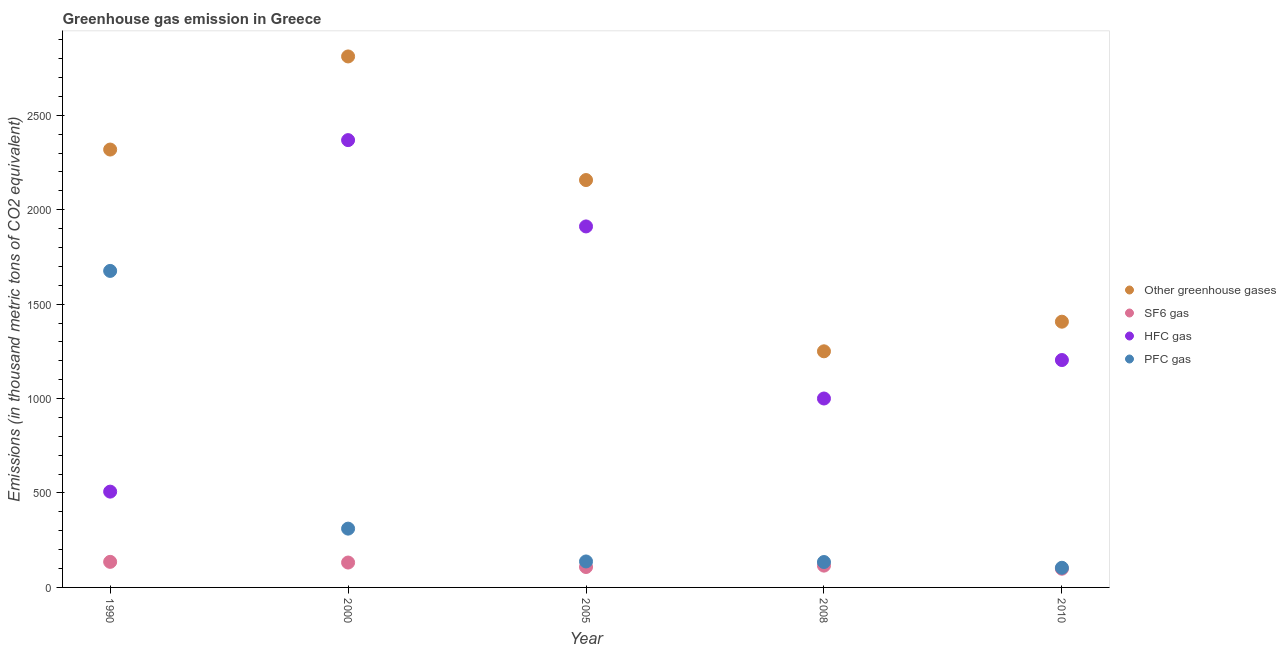How many different coloured dotlines are there?
Make the answer very short. 4. What is the emission of pfc gas in 2000?
Your response must be concise. 311.3. Across all years, what is the maximum emission of sf6 gas?
Your response must be concise. 135.4. Across all years, what is the minimum emission of hfc gas?
Keep it short and to the point. 507.2. In which year was the emission of sf6 gas minimum?
Give a very brief answer. 2010. What is the total emission of sf6 gas in the graph?
Offer a terse response. 589.7. What is the difference between the emission of hfc gas in 2000 and that in 2005?
Your response must be concise. 457. What is the difference between the emission of greenhouse gases in 2010 and the emission of sf6 gas in 1990?
Give a very brief answer. 1271.6. What is the average emission of pfc gas per year?
Offer a terse response. 472.64. In the year 2000, what is the difference between the emission of hfc gas and emission of sf6 gas?
Make the answer very short. 2236.6. In how many years, is the emission of hfc gas greater than 400 thousand metric tons?
Keep it short and to the point. 5. What is the ratio of the emission of pfc gas in 1990 to that in 2000?
Provide a succinct answer. 5.38. What is the difference between the highest and the second highest emission of sf6 gas?
Keep it short and to the point. 3.6. What is the difference between the highest and the lowest emission of pfc gas?
Ensure brevity in your answer.  1571.9. Is the sum of the emission of greenhouse gases in 1990 and 2008 greater than the maximum emission of hfc gas across all years?
Your answer should be very brief. Yes. Is it the case that in every year, the sum of the emission of sf6 gas and emission of greenhouse gases is greater than the sum of emission of pfc gas and emission of hfc gas?
Your response must be concise. Yes. Is it the case that in every year, the sum of the emission of greenhouse gases and emission of sf6 gas is greater than the emission of hfc gas?
Ensure brevity in your answer.  Yes. Does the emission of hfc gas monotonically increase over the years?
Keep it short and to the point. No. Is the emission of sf6 gas strictly greater than the emission of greenhouse gases over the years?
Your response must be concise. No. Is the emission of pfc gas strictly less than the emission of sf6 gas over the years?
Provide a succinct answer. No. How many years are there in the graph?
Provide a short and direct response. 5. Are the values on the major ticks of Y-axis written in scientific E-notation?
Your answer should be very brief. No. Does the graph contain any zero values?
Provide a short and direct response. No. Where does the legend appear in the graph?
Provide a short and direct response. Center right. How many legend labels are there?
Offer a very short reply. 4. How are the legend labels stacked?
Your answer should be very brief. Vertical. What is the title of the graph?
Provide a succinct answer. Greenhouse gas emission in Greece. Does "Bird species" appear as one of the legend labels in the graph?
Offer a terse response. No. What is the label or title of the X-axis?
Give a very brief answer. Year. What is the label or title of the Y-axis?
Keep it short and to the point. Emissions (in thousand metric tons of CO2 equivalent). What is the Emissions (in thousand metric tons of CO2 equivalent) of Other greenhouse gases in 1990?
Give a very brief answer. 2318.5. What is the Emissions (in thousand metric tons of CO2 equivalent) in SF6 gas in 1990?
Give a very brief answer. 135.4. What is the Emissions (in thousand metric tons of CO2 equivalent) in HFC gas in 1990?
Offer a very short reply. 507.2. What is the Emissions (in thousand metric tons of CO2 equivalent) in PFC gas in 1990?
Your answer should be very brief. 1675.9. What is the Emissions (in thousand metric tons of CO2 equivalent) in Other greenhouse gases in 2000?
Make the answer very short. 2811.5. What is the Emissions (in thousand metric tons of CO2 equivalent) of SF6 gas in 2000?
Provide a succinct answer. 131.8. What is the Emissions (in thousand metric tons of CO2 equivalent) of HFC gas in 2000?
Your answer should be compact. 2368.4. What is the Emissions (in thousand metric tons of CO2 equivalent) in PFC gas in 2000?
Keep it short and to the point. 311.3. What is the Emissions (in thousand metric tons of CO2 equivalent) in Other greenhouse gases in 2005?
Provide a succinct answer. 2157. What is the Emissions (in thousand metric tons of CO2 equivalent) of SF6 gas in 2005?
Ensure brevity in your answer.  108.1. What is the Emissions (in thousand metric tons of CO2 equivalent) of HFC gas in 2005?
Give a very brief answer. 1911.4. What is the Emissions (in thousand metric tons of CO2 equivalent) in PFC gas in 2005?
Make the answer very short. 137.5. What is the Emissions (in thousand metric tons of CO2 equivalent) in Other greenhouse gases in 2008?
Make the answer very short. 1250.2. What is the Emissions (in thousand metric tons of CO2 equivalent) of SF6 gas in 2008?
Keep it short and to the point. 115.4. What is the Emissions (in thousand metric tons of CO2 equivalent) of HFC gas in 2008?
Make the answer very short. 1000.3. What is the Emissions (in thousand metric tons of CO2 equivalent) in PFC gas in 2008?
Your answer should be compact. 134.5. What is the Emissions (in thousand metric tons of CO2 equivalent) in Other greenhouse gases in 2010?
Provide a short and direct response. 1407. What is the Emissions (in thousand metric tons of CO2 equivalent) in SF6 gas in 2010?
Ensure brevity in your answer.  99. What is the Emissions (in thousand metric tons of CO2 equivalent) of HFC gas in 2010?
Give a very brief answer. 1204. What is the Emissions (in thousand metric tons of CO2 equivalent) in PFC gas in 2010?
Offer a terse response. 104. Across all years, what is the maximum Emissions (in thousand metric tons of CO2 equivalent) in Other greenhouse gases?
Your answer should be compact. 2811.5. Across all years, what is the maximum Emissions (in thousand metric tons of CO2 equivalent) of SF6 gas?
Ensure brevity in your answer.  135.4. Across all years, what is the maximum Emissions (in thousand metric tons of CO2 equivalent) of HFC gas?
Offer a terse response. 2368.4. Across all years, what is the maximum Emissions (in thousand metric tons of CO2 equivalent) of PFC gas?
Provide a short and direct response. 1675.9. Across all years, what is the minimum Emissions (in thousand metric tons of CO2 equivalent) in Other greenhouse gases?
Your answer should be compact. 1250.2. Across all years, what is the minimum Emissions (in thousand metric tons of CO2 equivalent) in HFC gas?
Your response must be concise. 507.2. Across all years, what is the minimum Emissions (in thousand metric tons of CO2 equivalent) of PFC gas?
Keep it short and to the point. 104. What is the total Emissions (in thousand metric tons of CO2 equivalent) in Other greenhouse gases in the graph?
Provide a short and direct response. 9944.2. What is the total Emissions (in thousand metric tons of CO2 equivalent) of SF6 gas in the graph?
Your answer should be compact. 589.7. What is the total Emissions (in thousand metric tons of CO2 equivalent) in HFC gas in the graph?
Keep it short and to the point. 6991.3. What is the total Emissions (in thousand metric tons of CO2 equivalent) of PFC gas in the graph?
Offer a very short reply. 2363.2. What is the difference between the Emissions (in thousand metric tons of CO2 equivalent) in Other greenhouse gases in 1990 and that in 2000?
Provide a short and direct response. -493. What is the difference between the Emissions (in thousand metric tons of CO2 equivalent) in HFC gas in 1990 and that in 2000?
Your answer should be very brief. -1861.2. What is the difference between the Emissions (in thousand metric tons of CO2 equivalent) in PFC gas in 1990 and that in 2000?
Provide a short and direct response. 1364.6. What is the difference between the Emissions (in thousand metric tons of CO2 equivalent) in Other greenhouse gases in 1990 and that in 2005?
Ensure brevity in your answer.  161.5. What is the difference between the Emissions (in thousand metric tons of CO2 equivalent) in SF6 gas in 1990 and that in 2005?
Provide a succinct answer. 27.3. What is the difference between the Emissions (in thousand metric tons of CO2 equivalent) of HFC gas in 1990 and that in 2005?
Offer a very short reply. -1404.2. What is the difference between the Emissions (in thousand metric tons of CO2 equivalent) of PFC gas in 1990 and that in 2005?
Offer a terse response. 1538.4. What is the difference between the Emissions (in thousand metric tons of CO2 equivalent) of Other greenhouse gases in 1990 and that in 2008?
Offer a very short reply. 1068.3. What is the difference between the Emissions (in thousand metric tons of CO2 equivalent) of HFC gas in 1990 and that in 2008?
Give a very brief answer. -493.1. What is the difference between the Emissions (in thousand metric tons of CO2 equivalent) in PFC gas in 1990 and that in 2008?
Provide a short and direct response. 1541.4. What is the difference between the Emissions (in thousand metric tons of CO2 equivalent) in Other greenhouse gases in 1990 and that in 2010?
Keep it short and to the point. 911.5. What is the difference between the Emissions (in thousand metric tons of CO2 equivalent) in SF6 gas in 1990 and that in 2010?
Your answer should be very brief. 36.4. What is the difference between the Emissions (in thousand metric tons of CO2 equivalent) of HFC gas in 1990 and that in 2010?
Give a very brief answer. -696.8. What is the difference between the Emissions (in thousand metric tons of CO2 equivalent) of PFC gas in 1990 and that in 2010?
Give a very brief answer. 1571.9. What is the difference between the Emissions (in thousand metric tons of CO2 equivalent) of Other greenhouse gases in 2000 and that in 2005?
Your answer should be very brief. 654.5. What is the difference between the Emissions (in thousand metric tons of CO2 equivalent) of SF6 gas in 2000 and that in 2005?
Give a very brief answer. 23.7. What is the difference between the Emissions (in thousand metric tons of CO2 equivalent) of HFC gas in 2000 and that in 2005?
Your response must be concise. 457. What is the difference between the Emissions (in thousand metric tons of CO2 equivalent) of PFC gas in 2000 and that in 2005?
Your response must be concise. 173.8. What is the difference between the Emissions (in thousand metric tons of CO2 equivalent) in Other greenhouse gases in 2000 and that in 2008?
Provide a short and direct response. 1561.3. What is the difference between the Emissions (in thousand metric tons of CO2 equivalent) in SF6 gas in 2000 and that in 2008?
Keep it short and to the point. 16.4. What is the difference between the Emissions (in thousand metric tons of CO2 equivalent) of HFC gas in 2000 and that in 2008?
Provide a short and direct response. 1368.1. What is the difference between the Emissions (in thousand metric tons of CO2 equivalent) of PFC gas in 2000 and that in 2008?
Your response must be concise. 176.8. What is the difference between the Emissions (in thousand metric tons of CO2 equivalent) in Other greenhouse gases in 2000 and that in 2010?
Your answer should be very brief. 1404.5. What is the difference between the Emissions (in thousand metric tons of CO2 equivalent) of SF6 gas in 2000 and that in 2010?
Provide a succinct answer. 32.8. What is the difference between the Emissions (in thousand metric tons of CO2 equivalent) in HFC gas in 2000 and that in 2010?
Give a very brief answer. 1164.4. What is the difference between the Emissions (in thousand metric tons of CO2 equivalent) of PFC gas in 2000 and that in 2010?
Make the answer very short. 207.3. What is the difference between the Emissions (in thousand metric tons of CO2 equivalent) of Other greenhouse gases in 2005 and that in 2008?
Provide a succinct answer. 906.8. What is the difference between the Emissions (in thousand metric tons of CO2 equivalent) in HFC gas in 2005 and that in 2008?
Ensure brevity in your answer.  911.1. What is the difference between the Emissions (in thousand metric tons of CO2 equivalent) of PFC gas in 2005 and that in 2008?
Provide a succinct answer. 3. What is the difference between the Emissions (in thousand metric tons of CO2 equivalent) of Other greenhouse gases in 2005 and that in 2010?
Keep it short and to the point. 750. What is the difference between the Emissions (in thousand metric tons of CO2 equivalent) in SF6 gas in 2005 and that in 2010?
Provide a succinct answer. 9.1. What is the difference between the Emissions (in thousand metric tons of CO2 equivalent) of HFC gas in 2005 and that in 2010?
Your response must be concise. 707.4. What is the difference between the Emissions (in thousand metric tons of CO2 equivalent) of PFC gas in 2005 and that in 2010?
Provide a succinct answer. 33.5. What is the difference between the Emissions (in thousand metric tons of CO2 equivalent) in Other greenhouse gases in 2008 and that in 2010?
Offer a very short reply. -156.8. What is the difference between the Emissions (in thousand metric tons of CO2 equivalent) in HFC gas in 2008 and that in 2010?
Give a very brief answer. -203.7. What is the difference between the Emissions (in thousand metric tons of CO2 equivalent) in PFC gas in 2008 and that in 2010?
Provide a succinct answer. 30.5. What is the difference between the Emissions (in thousand metric tons of CO2 equivalent) of Other greenhouse gases in 1990 and the Emissions (in thousand metric tons of CO2 equivalent) of SF6 gas in 2000?
Provide a short and direct response. 2186.7. What is the difference between the Emissions (in thousand metric tons of CO2 equivalent) in Other greenhouse gases in 1990 and the Emissions (in thousand metric tons of CO2 equivalent) in HFC gas in 2000?
Give a very brief answer. -49.9. What is the difference between the Emissions (in thousand metric tons of CO2 equivalent) of Other greenhouse gases in 1990 and the Emissions (in thousand metric tons of CO2 equivalent) of PFC gas in 2000?
Offer a terse response. 2007.2. What is the difference between the Emissions (in thousand metric tons of CO2 equivalent) of SF6 gas in 1990 and the Emissions (in thousand metric tons of CO2 equivalent) of HFC gas in 2000?
Provide a short and direct response. -2233. What is the difference between the Emissions (in thousand metric tons of CO2 equivalent) of SF6 gas in 1990 and the Emissions (in thousand metric tons of CO2 equivalent) of PFC gas in 2000?
Your answer should be compact. -175.9. What is the difference between the Emissions (in thousand metric tons of CO2 equivalent) in HFC gas in 1990 and the Emissions (in thousand metric tons of CO2 equivalent) in PFC gas in 2000?
Make the answer very short. 195.9. What is the difference between the Emissions (in thousand metric tons of CO2 equivalent) in Other greenhouse gases in 1990 and the Emissions (in thousand metric tons of CO2 equivalent) in SF6 gas in 2005?
Offer a very short reply. 2210.4. What is the difference between the Emissions (in thousand metric tons of CO2 equivalent) of Other greenhouse gases in 1990 and the Emissions (in thousand metric tons of CO2 equivalent) of HFC gas in 2005?
Give a very brief answer. 407.1. What is the difference between the Emissions (in thousand metric tons of CO2 equivalent) in Other greenhouse gases in 1990 and the Emissions (in thousand metric tons of CO2 equivalent) in PFC gas in 2005?
Offer a terse response. 2181. What is the difference between the Emissions (in thousand metric tons of CO2 equivalent) in SF6 gas in 1990 and the Emissions (in thousand metric tons of CO2 equivalent) in HFC gas in 2005?
Keep it short and to the point. -1776. What is the difference between the Emissions (in thousand metric tons of CO2 equivalent) of SF6 gas in 1990 and the Emissions (in thousand metric tons of CO2 equivalent) of PFC gas in 2005?
Provide a short and direct response. -2.1. What is the difference between the Emissions (in thousand metric tons of CO2 equivalent) of HFC gas in 1990 and the Emissions (in thousand metric tons of CO2 equivalent) of PFC gas in 2005?
Provide a short and direct response. 369.7. What is the difference between the Emissions (in thousand metric tons of CO2 equivalent) of Other greenhouse gases in 1990 and the Emissions (in thousand metric tons of CO2 equivalent) of SF6 gas in 2008?
Make the answer very short. 2203.1. What is the difference between the Emissions (in thousand metric tons of CO2 equivalent) of Other greenhouse gases in 1990 and the Emissions (in thousand metric tons of CO2 equivalent) of HFC gas in 2008?
Ensure brevity in your answer.  1318.2. What is the difference between the Emissions (in thousand metric tons of CO2 equivalent) of Other greenhouse gases in 1990 and the Emissions (in thousand metric tons of CO2 equivalent) of PFC gas in 2008?
Provide a succinct answer. 2184. What is the difference between the Emissions (in thousand metric tons of CO2 equivalent) in SF6 gas in 1990 and the Emissions (in thousand metric tons of CO2 equivalent) in HFC gas in 2008?
Make the answer very short. -864.9. What is the difference between the Emissions (in thousand metric tons of CO2 equivalent) in HFC gas in 1990 and the Emissions (in thousand metric tons of CO2 equivalent) in PFC gas in 2008?
Your answer should be very brief. 372.7. What is the difference between the Emissions (in thousand metric tons of CO2 equivalent) in Other greenhouse gases in 1990 and the Emissions (in thousand metric tons of CO2 equivalent) in SF6 gas in 2010?
Your answer should be compact. 2219.5. What is the difference between the Emissions (in thousand metric tons of CO2 equivalent) in Other greenhouse gases in 1990 and the Emissions (in thousand metric tons of CO2 equivalent) in HFC gas in 2010?
Your response must be concise. 1114.5. What is the difference between the Emissions (in thousand metric tons of CO2 equivalent) in Other greenhouse gases in 1990 and the Emissions (in thousand metric tons of CO2 equivalent) in PFC gas in 2010?
Offer a terse response. 2214.5. What is the difference between the Emissions (in thousand metric tons of CO2 equivalent) in SF6 gas in 1990 and the Emissions (in thousand metric tons of CO2 equivalent) in HFC gas in 2010?
Offer a terse response. -1068.6. What is the difference between the Emissions (in thousand metric tons of CO2 equivalent) of SF6 gas in 1990 and the Emissions (in thousand metric tons of CO2 equivalent) of PFC gas in 2010?
Make the answer very short. 31.4. What is the difference between the Emissions (in thousand metric tons of CO2 equivalent) of HFC gas in 1990 and the Emissions (in thousand metric tons of CO2 equivalent) of PFC gas in 2010?
Your answer should be very brief. 403.2. What is the difference between the Emissions (in thousand metric tons of CO2 equivalent) of Other greenhouse gases in 2000 and the Emissions (in thousand metric tons of CO2 equivalent) of SF6 gas in 2005?
Provide a succinct answer. 2703.4. What is the difference between the Emissions (in thousand metric tons of CO2 equivalent) in Other greenhouse gases in 2000 and the Emissions (in thousand metric tons of CO2 equivalent) in HFC gas in 2005?
Keep it short and to the point. 900.1. What is the difference between the Emissions (in thousand metric tons of CO2 equivalent) of Other greenhouse gases in 2000 and the Emissions (in thousand metric tons of CO2 equivalent) of PFC gas in 2005?
Your answer should be compact. 2674. What is the difference between the Emissions (in thousand metric tons of CO2 equivalent) in SF6 gas in 2000 and the Emissions (in thousand metric tons of CO2 equivalent) in HFC gas in 2005?
Make the answer very short. -1779.6. What is the difference between the Emissions (in thousand metric tons of CO2 equivalent) of HFC gas in 2000 and the Emissions (in thousand metric tons of CO2 equivalent) of PFC gas in 2005?
Ensure brevity in your answer.  2230.9. What is the difference between the Emissions (in thousand metric tons of CO2 equivalent) of Other greenhouse gases in 2000 and the Emissions (in thousand metric tons of CO2 equivalent) of SF6 gas in 2008?
Your response must be concise. 2696.1. What is the difference between the Emissions (in thousand metric tons of CO2 equivalent) of Other greenhouse gases in 2000 and the Emissions (in thousand metric tons of CO2 equivalent) of HFC gas in 2008?
Keep it short and to the point. 1811.2. What is the difference between the Emissions (in thousand metric tons of CO2 equivalent) in Other greenhouse gases in 2000 and the Emissions (in thousand metric tons of CO2 equivalent) in PFC gas in 2008?
Offer a very short reply. 2677. What is the difference between the Emissions (in thousand metric tons of CO2 equivalent) of SF6 gas in 2000 and the Emissions (in thousand metric tons of CO2 equivalent) of HFC gas in 2008?
Make the answer very short. -868.5. What is the difference between the Emissions (in thousand metric tons of CO2 equivalent) in SF6 gas in 2000 and the Emissions (in thousand metric tons of CO2 equivalent) in PFC gas in 2008?
Give a very brief answer. -2.7. What is the difference between the Emissions (in thousand metric tons of CO2 equivalent) in HFC gas in 2000 and the Emissions (in thousand metric tons of CO2 equivalent) in PFC gas in 2008?
Provide a succinct answer. 2233.9. What is the difference between the Emissions (in thousand metric tons of CO2 equivalent) of Other greenhouse gases in 2000 and the Emissions (in thousand metric tons of CO2 equivalent) of SF6 gas in 2010?
Give a very brief answer. 2712.5. What is the difference between the Emissions (in thousand metric tons of CO2 equivalent) in Other greenhouse gases in 2000 and the Emissions (in thousand metric tons of CO2 equivalent) in HFC gas in 2010?
Keep it short and to the point. 1607.5. What is the difference between the Emissions (in thousand metric tons of CO2 equivalent) in Other greenhouse gases in 2000 and the Emissions (in thousand metric tons of CO2 equivalent) in PFC gas in 2010?
Provide a succinct answer. 2707.5. What is the difference between the Emissions (in thousand metric tons of CO2 equivalent) in SF6 gas in 2000 and the Emissions (in thousand metric tons of CO2 equivalent) in HFC gas in 2010?
Offer a terse response. -1072.2. What is the difference between the Emissions (in thousand metric tons of CO2 equivalent) in SF6 gas in 2000 and the Emissions (in thousand metric tons of CO2 equivalent) in PFC gas in 2010?
Make the answer very short. 27.8. What is the difference between the Emissions (in thousand metric tons of CO2 equivalent) of HFC gas in 2000 and the Emissions (in thousand metric tons of CO2 equivalent) of PFC gas in 2010?
Provide a short and direct response. 2264.4. What is the difference between the Emissions (in thousand metric tons of CO2 equivalent) in Other greenhouse gases in 2005 and the Emissions (in thousand metric tons of CO2 equivalent) in SF6 gas in 2008?
Offer a terse response. 2041.6. What is the difference between the Emissions (in thousand metric tons of CO2 equivalent) in Other greenhouse gases in 2005 and the Emissions (in thousand metric tons of CO2 equivalent) in HFC gas in 2008?
Offer a very short reply. 1156.7. What is the difference between the Emissions (in thousand metric tons of CO2 equivalent) of Other greenhouse gases in 2005 and the Emissions (in thousand metric tons of CO2 equivalent) of PFC gas in 2008?
Keep it short and to the point. 2022.5. What is the difference between the Emissions (in thousand metric tons of CO2 equivalent) of SF6 gas in 2005 and the Emissions (in thousand metric tons of CO2 equivalent) of HFC gas in 2008?
Your answer should be compact. -892.2. What is the difference between the Emissions (in thousand metric tons of CO2 equivalent) in SF6 gas in 2005 and the Emissions (in thousand metric tons of CO2 equivalent) in PFC gas in 2008?
Make the answer very short. -26.4. What is the difference between the Emissions (in thousand metric tons of CO2 equivalent) in HFC gas in 2005 and the Emissions (in thousand metric tons of CO2 equivalent) in PFC gas in 2008?
Offer a very short reply. 1776.9. What is the difference between the Emissions (in thousand metric tons of CO2 equivalent) in Other greenhouse gases in 2005 and the Emissions (in thousand metric tons of CO2 equivalent) in SF6 gas in 2010?
Your response must be concise. 2058. What is the difference between the Emissions (in thousand metric tons of CO2 equivalent) of Other greenhouse gases in 2005 and the Emissions (in thousand metric tons of CO2 equivalent) of HFC gas in 2010?
Ensure brevity in your answer.  953. What is the difference between the Emissions (in thousand metric tons of CO2 equivalent) of Other greenhouse gases in 2005 and the Emissions (in thousand metric tons of CO2 equivalent) of PFC gas in 2010?
Provide a succinct answer. 2053. What is the difference between the Emissions (in thousand metric tons of CO2 equivalent) of SF6 gas in 2005 and the Emissions (in thousand metric tons of CO2 equivalent) of HFC gas in 2010?
Make the answer very short. -1095.9. What is the difference between the Emissions (in thousand metric tons of CO2 equivalent) in SF6 gas in 2005 and the Emissions (in thousand metric tons of CO2 equivalent) in PFC gas in 2010?
Your answer should be very brief. 4.1. What is the difference between the Emissions (in thousand metric tons of CO2 equivalent) of HFC gas in 2005 and the Emissions (in thousand metric tons of CO2 equivalent) of PFC gas in 2010?
Provide a short and direct response. 1807.4. What is the difference between the Emissions (in thousand metric tons of CO2 equivalent) in Other greenhouse gases in 2008 and the Emissions (in thousand metric tons of CO2 equivalent) in SF6 gas in 2010?
Offer a terse response. 1151.2. What is the difference between the Emissions (in thousand metric tons of CO2 equivalent) in Other greenhouse gases in 2008 and the Emissions (in thousand metric tons of CO2 equivalent) in HFC gas in 2010?
Make the answer very short. 46.2. What is the difference between the Emissions (in thousand metric tons of CO2 equivalent) of Other greenhouse gases in 2008 and the Emissions (in thousand metric tons of CO2 equivalent) of PFC gas in 2010?
Your answer should be compact. 1146.2. What is the difference between the Emissions (in thousand metric tons of CO2 equivalent) in SF6 gas in 2008 and the Emissions (in thousand metric tons of CO2 equivalent) in HFC gas in 2010?
Give a very brief answer. -1088.6. What is the difference between the Emissions (in thousand metric tons of CO2 equivalent) in SF6 gas in 2008 and the Emissions (in thousand metric tons of CO2 equivalent) in PFC gas in 2010?
Offer a terse response. 11.4. What is the difference between the Emissions (in thousand metric tons of CO2 equivalent) in HFC gas in 2008 and the Emissions (in thousand metric tons of CO2 equivalent) in PFC gas in 2010?
Offer a very short reply. 896.3. What is the average Emissions (in thousand metric tons of CO2 equivalent) in Other greenhouse gases per year?
Your response must be concise. 1988.84. What is the average Emissions (in thousand metric tons of CO2 equivalent) in SF6 gas per year?
Your answer should be compact. 117.94. What is the average Emissions (in thousand metric tons of CO2 equivalent) in HFC gas per year?
Provide a short and direct response. 1398.26. What is the average Emissions (in thousand metric tons of CO2 equivalent) in PFC gas per year?
Offer a terse response. 472.64. In the year 1990, what is the difference between the Emissions (in thousand metric tons of CO2 equivalent) of Other greenhouse gases and Emissions (in thousand metric tons of CO2 equivalent) of SF6 gas?
Provide a succinct answer. 2183.1. In the year 1990, what is the difference between the Emissions (in thousand metric tons of CO2 equivalent) of Other greenhouse gases and Emissions (in thousand metric tons of CO2 equivalent) of HFC gas?
Your answer should be compact. 1811.3. In the year 1990, what is the difference between the Emissions (in thousand metric tons of CO2 equivalent) of Other greenhouse gases and Emissions (in thousand metric tons of CO2 equivalent) of PFC gas?
Your response must be concise. 642.6. In the year 1990, what is the difference between the Emissions (in thousand metric tons of CO2 equivalent) in SF6 gas and Emissions (in thousand metric tons of CO2 equivalent) in HFC gas?
Your answer should be very brief. -371.8. In the year 1990, what is the difference between the Emissions (in thousand metric tons of CO2 equivalent) of SF6 gas and Emissions (in thousand metric tons of CO2 equivalent) of PFC gas?
Provide a short and direct response. -1540.5. In the year 1990, what is the difference between the Emissions (in thousand metric tons of CO2 equivalent) of HFC gas and Emissions (in thousand metric tons of CO2 equivalent) of PFC gas?
Offer a terse response. -1168.7. In the year 2000, what is the difference between the Emissions (in thousand metric tons of CO2 equivalent) of Other greenhouse gases and Emissions (in thousand metric tons of CO2 equivalent) of SF6 gas?
Your answer should be compact. 2679.7. In the year 2000, what is the difference between the Emissions (in thousand metric tons of CO2 equivalent) of Other greenhouse gases and Emissions (in thousand metric tons of CO2 equivalent) of HFC gas?
Your answer should be compact. 443.1. In the year 2000, what is the difference between the Emissions (in thousand metric tons of CO2 equivalent) in Other greenhouse gases and Emissions (in thousand metric tons of CO2 equivalent) in PFC gas?
Ensure brevity in your answer.  2500.2. In the year 2000, what is the difference between the Emissions (in thousand metric tons of CO2 equivalent) of SF6 gas and Emissions (in thousand metric tons of CO2 equivalent) of HFC gas?
Your answer should be very brief. -2236.6. In the year 2000, what is the difference between the Emissions (in thousand metric tons of CO2 equivalent) of SF6 gas and Emissions (in thousand metric tons of CO2 equivalent) of PFC gas?
Provide a short and direct response. -179.5. In the year 2000, what is the difference between the Emissions (in thousand metric tons of CO2 equivalent) of HFC gas and Emissions (in thousand metric tons of CO2 equivalent) of PFC gas?
Give a very brief answer. 2057.1. In the year 2005, what is the difference between the Emissions (in thousand metric tons of CO2 equivalent) of Other greenhouse gases and Emissions (in thousand metric tons of CO2 equivalent) of SF6 gas?
Give a very brief answer. 2048.9. In the year 2005, what is the difference between the Emissions (in thousand metric tons of CO2 equivalent) of Other greenhouse gases and Emissions (in thousand metric tons of CO2 equivalent) of HFC gas?
Your response must be concise. 245.6. In the year 2005, what is the difference between the Emissions (in thousand metric tons of CO2 equivalent) of Other greenhouse gases and Emissions (in thousand metric tons of CO2 equivalent) of PFC gas?
Your answer should be very brief. 2019.5. In the year 2005, what is the difference between the Emissions (in thousand metric tons of CO2 equivalent) in SF6 gas and Emissions (in thousand metric tons of CO2 equivalent) in HFC gas?
Provide a short and direct response. -1803.3. In the year 2005, what is the difference between the Emissions (in thousand metric tons of CO2 equivalent) of SF6 gas and Emissions (in thousand metric tons of CO2 equivalent) of PFC gas?
Offer a terse response. -29.4. In the year 2005, what is the difference between the Emissions (in thousand metric tons of CO2 equivalent) in HFC gas and Emissions (in thousand metric tons of CO2 equivalent) in PFC gas?
Ensure brevity in your answer.  1773.9. In the year 2008, what is the difference between the Emissions (in thousand metric tons of CO2 equivalent) in Other greenhouse gases and Emissions (in thousand metric tons of CO2 equivalent) in SF6 gas?
Offer a terse response. 1134.8. In the year 2008, what is the difference between the Emissions (in thousand metric tons of CO2 equivalent) of Other greenhouse gases and Emissions (in thousand metric tons of CO2 equivalent) of HFC gas?
Provide a short and direct response. 249.9. In the year 2008, what is the difference between the Emissions (in thousand metric tons of CO2 equivalent) of Other greenhouse gases and Emissions (in thousand metric tons of CO2 equivalent) of PFC gas?
Ensure brevity in your answer.  1115.7. In the year 2008, what is the difference between the Emissions (in thousand metric tons of CO2 equivalent) of SF6 gas and Emissions (in thousand metric tons of CO2 equivalent) of HFC gas?
Your answer should be very brief. -884.9. In the year 2008, what is the difference between the Emissions (in thousand metric tons of CO2 equivalent) in SF6 gas and Emissions (in thousand metric tons of CO2 equivalent) in PFC gas?
Provide a short and direct response. -19.1. In the year 2008, what is the difference between the Emissions (in thousand metric tons of CO2 equivalent) of HFC gas and Emissions (in thousand metric tons of CO2 equivalent) of PFC gas?
Keep it short and to the point. 865.8. In the year 2010, what is the difference between the Emissions (in thousand metric tons of CO2 equivalent) in Other greenhouse gases and Emissions (in thousand metric tons of CO2 equivalent) in SF6 gas?
Make the answer very short. 1308. In the year 2010, what is the difference between the Emissions (in thousand metric tons of CO2 equivalent) of Other greenhouse gases and Emissions (in thousand metric tons of CO2 equivalent) of HFC gas?
Keep it short and to the point. 203. In the year 2010, what is the difference between the Emissions (in thousand metric tons of CO2 equivalent) of Other greenhouse gases and Emissions (in thousand metric tons of CO2 equivalent) of PFC gas?
Your answer should be compact. 1303. In the year 2010, what is the difference between the Emissions (in thousand metric tons of CO2 equivalent) of SF6 gas and Emissions (in thousand metric tons of CO2 equivalent) of HFC gas?
Provide a succinct answer. -1105. In the year 2010, what is the difference between the Emissions (in thousand metric tons of CO2 equivalent) of HFC gas and Emissions (in thousand metric tons of CO2 equivalent) of PFC gas?
Make the answer very short. 1100. What is the ratio of the Emissions (in thousand metric tons of CO2 equivalent) of Other greenhouse gases in 1990 to that in 2000?
Offer a terse response. 0.82. What is the ratio of the Emissions (in thousand metric tons of CO2 equivalent) of SF6 gas in 1990 to that in 2000?
Your answer should be compact. 1.03. What is the ratio of the Emissions (in thousand metric tons of CO2 equivalent) in HFC gas in 1990 to that in 2000?
Offer a very short reply. 0.21. What is the ratio of the Emissions (in thousand metric tons of CO2 equivalent) in PFC gas in 1990 to that in 2000?
Your response must be concise. 5.38. What is the ratio of the Emissions (in thousand metric tons of CO2 equivalent) in Other greenhouse gases in 1990 to that in 2005?
Make the answer very short. 1.07. What is the ratio of the Emissions (in thousand metric tons of CO2 equivalent) in SF6 gas in 1990 to that in 2005?
Your answer should be very brief. 1.25. What is the ratio of the Emissions (in thousand metric tons of CO2 equivalent) of HFC gas in 1990 to that in 2005?
Keep it short and to the point. 0.27. What is the ratio of the Emissions (in thousand metric tons of CO2 equivalent) in PFC gas in 1990 to that in 2005?
Keep it short and to the point. 12.19. What is the ratio of the Emissions (in thousand metric tons of CO2 equivalent) in Other greenhouse gases in 1990 to that in 2008?
Provide a succinct answer. 1.85. What is the ratio of the Emissions (in thousand metric tons of CO2 equivalent) in SF6 gas in 1990 to that in 2008?
Give a very brief answer. 1.17. What is the ratio of the Emissions (in thousand metric tons of CO2 equivalent) in HFC gas in 1990 to that in 2008?
Ensure brevity in your answer.  0.51. What is the ratio of the Emissions (in thousand metric tons of CO2 equivalent) in PFC gas in 1990 to that in 2008?
Your answer should be compact. 12.46. What is the ratio of the Emissions (in thousand metric tons of CO2 equivalent) of Other greenhouse gases in 1990 to that in 2010?
Your response must be concise. 1.65. What is the ratio of the Emissions (in thousand metric tons of CO2 equivalent) of SF6 gas in 1990 to that in 2010?
Your answer should be compact. 1.37. What is the ratio of the Emissions (in thousand metric tons of CO2 equivalent) of HFC gas in 1990 to that in 2010?
Provide a succinct answer. 0.42. What is the ratio of the Emissions (in thousand metric tons of CO2 equivalent) in PFC gas in 1990 to that in 2010?
Ensure brevity in your answer.  16.11. What is the ratio of the Emissions (in thousand metric tons of CO2 equivalent) in Other greenhouse gases in 2000 to that in 2005?
Your answer should be very brief. 1.3. What is the ratio of the Emissions (in thousand metric tons of CO2 equivalent) of SF6 gas in 2000 to that in 2005?
Your answer should be compact. 1.22. What is the ratio of the Emissions (in thousand metric tons of CO2 equivalent) of HFC gas in 2000 to that in 2005?
Provide a short and direct response. 1.24. What is the ratio of the Emissions (in thousand metric tons of CO2 equivalent) in PFC gas in 2000 to that in 2005?
Provide a succinct answer. 2.26. What is the ratio of the Emissions (in thousand metric tons of CO2 equivalent) of Other greenhouse gases in 2000 to that in 2008?
Make the answer very short. 2.25. What is the ratio of the Emissions (in thousand metric tons of CO2 equivalent) of SF6 gas in 2000 to that in 2008?
Make the answer very short. 1.14. What is the ratio of the Emissions (in thousand metric tons of CO2 equivalent) in HFC gas in 2000 to that in 2008?
Your answer should be compact. 2.37. What is the ratio of the Emissions (in thousand metric tons of CO2 equivalent) in PFC gas in 2000 to that in 2008?
Ensure brevity in your answer.  2.31. What is the ratio of the Emissions (in thousand metric tons of CO2 equivalent) in Other greenhouse gases in 2000 to that in 2010?
Your response must be concise. 2. What is the ratio of the Emissions (in thousand metric tons of CO2 equivalent) in SF6 gas in 2000 to that in 2010?
Offer a very short reply. 1.33. What is the ratio of the Emissions (in thousand metric tons of CO2 equivalent) of HFC gas in 2000 to that in 2010?
Offer a very short reply. 1.97. What is the ratio of the Emissions (in thousand metric tons of CO2 equivalent) in PFC gas in 2000 to that in 2010?
Offer a terse response. 2.99. What is the ratio of the Emissions (in thousand metric tons of CO2 equivalent) of Other greenhouse gases in 2005 to that in 2008?
Offer a very short reply. 1.73. What is the ratio of the Emissions (in thousand metric tons of CO2 equivalent) of SF6 gas in 2005 to that in 2008?
Give a very brief answer. 0.94. What is the ratio of the Emissions (in thousand metric tons of CO2 equivalent) in HFC gas in 2005 to that in 2008?
Ensure brevity in your answer.  1.91. What is the ratio of the Emissions (in thousand metric tons of CO2 equivalent) in PFC gas in 2005 to that in 2008?
Your response must be concise. 1.02. What is the ratio of the Emissions (in thousand metric tons of CO2 equivalent) in Other greenhouse gases in 2005 to that in 2010?
Offer a very short reply. 1.53. What is the ratio of the Emissions (in thousand metric tons of CO2 equivalent) in SF6 gas in 2005 to that in 2010?
Your answer should be very brief. 1.09. What is the ratio of the Emissions (in thousand metric tons of CO2 equivalent) of HFC gas in 2005 to that in 2010?
Provide a succinct answer. 1.59. What is the ratio of the Emissions (in thousand metric tons of CO2 equivalent) of PFC gas in 2005 to that in 2010?
Give a very brief answer. 1.32. What is the ratio of the Emissions (in thousand metric tons of CO2 equivalent) of Other greenhouse gases in 2008 to that in 2010?
Your answer should be very brief. 0.89. What is the ratio of the Emissions (in thousand metric tons of CO2 equivalent) in SF6 gas in 2008 to that in 2010?
Your answer should be very brief. 1.17. What is the ratio of the Emissions (in thousand metric tons of CO2 equivalent) in HFC gas in 2008 to that in 2010?
Ensure brevity in your answer.  0.83. What is the ratio of the Emissions (in thousand metric tons of CO2 equivalent) of PFC gas in 2008 to that in 2010?
Your answer should be compact. 1.29. What is the difference between the highest and the second highest Emissions (in thousand metric tons of CO2 equivalent) in Other greenhouse gases?
Make the answer very short. 493. What is the difference between the highest and the second highest Emissions (in thousand metric tons of CO2 equivalent) in HFC gas?
Your answer should be very brief. 457. What is the difference between the highest and the second highest Emissions (in thousand metric tons of CO2 equivalent) in PFC gas?
Make the answer very short. 1364.6. What is the difference between the highest and the lowest Emissions (in thousand metric tons of CO2 equivalent) in Other greenhouse gases?
Provide a short and direct response. 1561.3. What is the difference between the highest and the lowest Emissions (in thousand metric tons of CO2 equivalent) of SF6 gas?
Your answer should be very brief. 36.4. What is the difference between the highest and the lowest Emissions (in thousand metric tons of CO2 equivalent) of HFC gas?
Give a very brief answer. 1861.2. What is the difference between the highest and the lowest Emissions (in thousand metric tons of CO2 equivalent) in PFC gas?
Provide a succinct answer. 1571.9. 